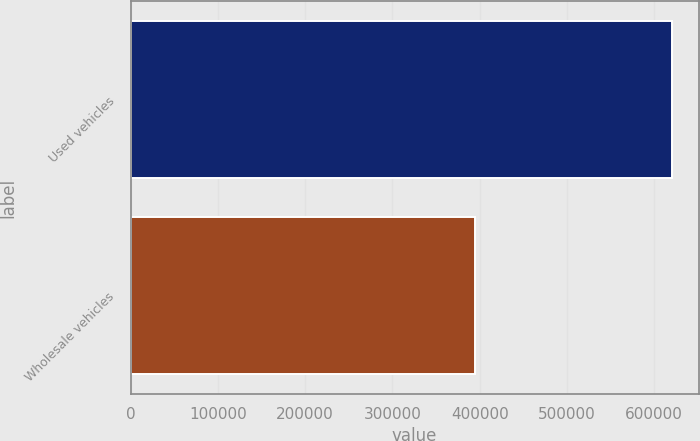Convert chart. <chart><loc_0><loc_0><loc_500><loc_500><bar_chart><fcel>Used vehicles<fcel>Wholesale vehicles<nl><fcel>619936<fcel>394437<nl></chart> 